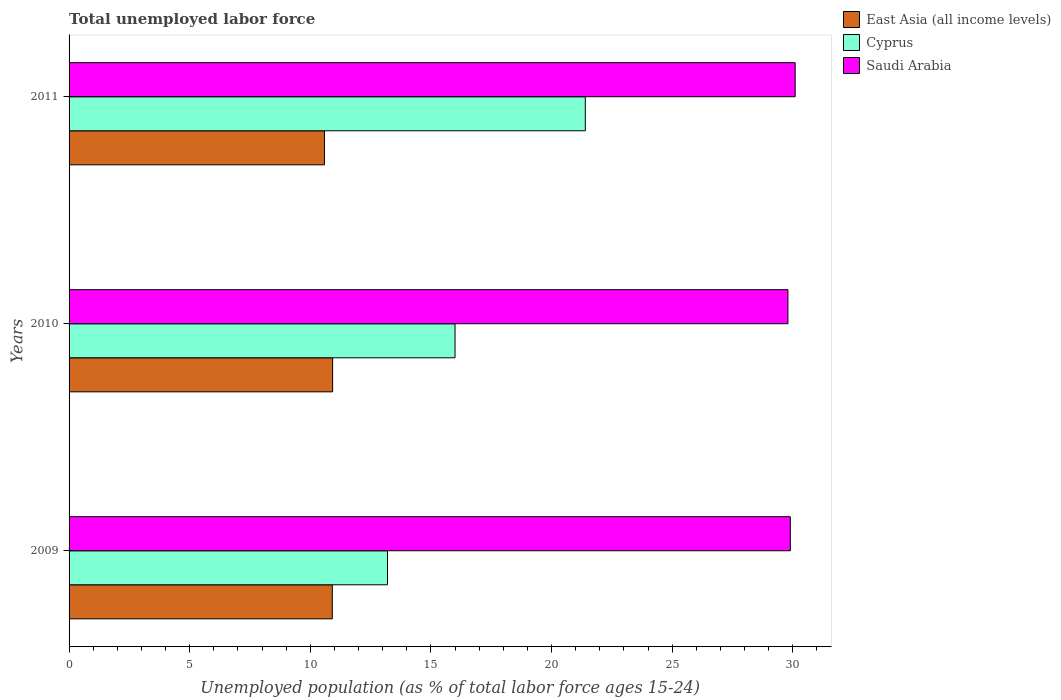How many groups of bars are there?
Your answer should be compact. 3. How many bars are there on the 3rd tick from the top?
Keep it short and to the point. 3. Across all years, what is the maximum percentage of unemployed population in in Saudi Arabia?
Your answer should be compact. 30.1. Across all years, what is the minimum percentage of unemployed population in in East Asia (all income levels)?
Your answer should be very brief. 10.59. In which year was the percentage of unemployed population in in Saudi Arabia maximum?
Your answer should be very brief. 2011. What is the total percentage of unemployed population in in Cyprus in the graph?
Offer a terse response. 50.6. What is the difference between the percentage of unemployed population in in East Asia (all income levels) in 2009 and that in 2011?
Your answer should be very brief. 0.33. What is the difference between the percentage of unemployed population in in East Asia (all income levels) in 2009 and the percentage of unemployed population in in Saudi Arabia in 2011?
Provide a succinct answer. -19.19. What is the average percentage of unemployed population in in Cyprus per year?
Provide a short and direct response. 16.87. In the year 2011, what is the difference between the percentage of unemployed population in in Saudi Arabia and percentage of unemployed population in in Cyprus?
Your response must be concise. 8.7. In how many years, is the percentage of unemployed population in in Cyprus greater than 14 %?
Give a very brief answer. 2. What is the ratio of the percentage of unemployed population in in East Asia (all income levels) in 2010 to that in 2011?
Offer a terse response. 1.03. Is the percentage of unemployed population in in East Asia (all income levels) in 2010 less than that in 2011?
Provide a succinct answer. No. Is the difference between the percentage of unemployed population in in Saudi Arabia in 2009 and 2011 greater than the difference between the percentage of unemployed population in in Cyprus in 2009 and 2011?
Make the answer very short. Yes. What is the difference between the highest and the second highest percentage of unemployed population in in Saudi Arabia?
Offer a terse response. 0.2. What is the difference between the highest and the lowest percentage of unemployed population in in Saudi Arabia?
Your answer should be very brief. 0.3. In how many years, is the percentage of unemployed population in in East Asia (all income levels) greater than the average percentage of unemployed population in in East Asia (all income levels) taken over all years?
Ensure brevity in your answer.  2. Is the sum of the percentage of unemployed population in in East Asia (all income levels) in 2010 and 2011 greater than the maximum percentage of unemployed population in in Saudi Arabia across all years?
Give a very brief answer. No. What does the 2nd bar from the top in 2011 represents?
Keep it short and to the point. Cyprus. What does the 2nd bar from the bottom in 2011 represents?
Make the answer very short. Cyprus. Is it the case that in every year, the sum of the percentage of unemployed population in in Cyprus and percentage of unemployed population in in East Asia (all income levels) is greater than the percentage of unemployed population in in Saudi Arabia?
Make the answer very short. No. Are all the bars in the graph horizontal?
Offer a very short reply. Yes. How many years are there in the graph?
Offer a terse response. 3. What is the difference between two consecutive major ticks on the X-axis?
Ensure brevity in your answer.  5. Are the values on the major ticks of X-axis written in scientific E-notation?
Your answer should be very brief. No. How many legend labels are there?
Ensure brevity in your answer.  3. How are the legend labels stacked?
Provide a short and direct response. Vertical. What is the title of the graph?
Offer a very short reply. Total unemployed labor force. Does "Chad" appear as one of the legend labels in the graph?
Your response must be concise. No. What is the label or title of the X-axis?
Your answer should be compact. Unemployed population (as % of total labor force ages 15-24). What is the label or title of the Y-axis?
Offer a terse response. Years. What is the Unemployed population (as % of total labor force ages 15-24) in East Asia (all income levels) in 2009?
Provide a short and direct response. 10.91. What is the Unemployed population (as % of total labor force ages 15-24) in Cyprus in 2009?
Ensure brevity in your answer.  13.2. What is the Unemployed population (as % of total labor force ages 15-24) of Saudi Arabia in 2009?
Your response must be concise. 29.9. What is the Unemployed population (as % of total labor force ages 15-24) in East Asia (all income levels) in 2010?
Your answer should be compact. 10.93. What is the Unemployed population (as % of total labor force ages 15-24) in Saudi Arabia in 2010?
Your response must be concise. 29.8. What is the Unemployed population (as % of total labor force ages 15-24) in East Asia (all income levels) in 2011?
Offer a very short reply. 10.59. What is the Unemployed population (as % of total labor force ages 15-24) of Cyprus in 2011?
Your answer should be very brief. 21.4. What is the Unemployed population (as % of total labor force ages 15-24) in Saudi Arabia in 2011?
Provide a succinct answer. 30.1. Across all years, what is the maximum Unemployed population (as % of total labor force ages 15-24) of East Asia (all income levels)?
Provide a succinct answer. 10.93. Across all years, what is the maximum Unemployed population (as % of total labor force ages 15-24) in Cyprus?
Keep it short and to the point. 21.4. Across all years, what is the maximum Unemployed population (as % of total labor force ages 15-24) in Saudi Arabia?
Provide a short and direct response. 30.1. Across all years, what is the minimum Unemployed population (as % of total labor force ages 15-24) in East Asia (all income levels)?
Keep it short and to the point. 10.59. Across all years, what is the minimum Unemployed population (as % of total labor force ages 15-24) in Cyprus?
Keep it short and to the point. 13.2. Across all years, what is the minimum Unemployed population (as % of total labor force ages 15-24) of Saudi Arabia?
Keep it short and to the point. 29.8. What is the total Unemployed population (as % of total labor force ages 15-24) of East Asia (all income levels) in the graph?
Provide a succinct answer. 32.42. What is the total Unemployed population (as % of total labor force ages 15-24) in Cyprus in the graph?
Ensure brevity in your answer.  50.6. What is the total Unemployed population (as % of total labor force ages 15-24) in Saudi Arabia in the graph?
Offer a terse response. 89.8. What is the difference between the Unemployed population (as % of total labor force ages 15-24) in East Asia (all income levels) in 2009 and that in 2010?
Your answer should be compact. -0.01. What is the difference between the Unemployed population (as % of total labor force ages 15-24) of Cyprus in 2009 and that in 2010?
Make the answer very short. -2.8. What is the difference between the Unemployed population (as % of total labor force ages 15-24) in East Asia (all income levels) in 2009 and that in 2011?
Your response must be concise. 0.33. What is the difference between the Unemployed population (as % of total labor force ages 15-24) in Saudi Arabia in 2009 and that in 2011?
Give a very brief answer. -0.2. What is the difference between the Unemployed population (as % of total labor force ages 15-24) of East Asia (all income levels) in 2010 and that in 2011?
Your answer should be very brief. 0.34. What is the difference between the Unemployed population (as % of total labor force ages 15-24) of East Asia (all income levels) in 2009 and the Unemployed population (as % of total labor force ages 15-24) of Cyprus in 2010?
Keep it short and to the point. -5.09. What is the difference between the Unemployed population (as % of total labor force ages 15-24) of East Asia (all income levels) in 2009 and the Unemployed population (as % of total labor force ages 15-24) of Saudi Arabia in 2010?
Your answer should be compact. -18.89. What is the difference between the Unemployed population (as % of total labor force ages 15-24) of Cyprus in 2009 and the Unemployed population (as % of total labor force ages 15-24) of Saudi Arabia in 2010?
Your answer should be very brief. -16.6. What is the difference between the Unemployed population (as % of total labor force ages 15-24) in East Asia (all income levels) in 2009 and the Unemployed population (as % of total labor force ages 15-24) in Cyprus in 2011?
Give a very brief answer. -10.49. What is the difference between the Unemployed population (as % of total labor force ages 15-24) in East Asia (all income levels) in 2009 and the Unemployed population (as % of total labor force ages 15-24) in Saudi Arabia in 2011?
Keep it short and to the point. -19.19. What is the difference between the Unemployed population (as % of total labor force ages 15-24) in Cyprus in 2009 and the Unemployed population (as % of total labor force ages 15-24) in Saudi Arabia in 2011?
Make the answer very short. -16.9. What is the difference between the Unemployed population (as % of total labor force ages 15-24) in East Asia (all income levels) in 2010 and the Unemployed population (as % of total labor force ages 15-24) in Cyprus in 2011?
Provide a succinct answer. -10.47. What is the difference between the Unemployed population (as % of total labor force ages 15-24) of East Asia (all income levels) in 2010 and the Unemployed population (as % of total labor force ages 15-24) of Saudi Arabia in 2011?
Your answer should be very brief. -19.17. What is the difference between the Unemployed population (as % of total labor force ages 15-24) in Cyprus in 2010 and the Unemployed population (as % of total labor force ages 15-24) in Saudi Arabia in 2011?
Your answer should be compact. -14.1. What is the average Unemployed population (as % of total labor force ages 15-24) in East Asia (all income levels) per year?
Your response must be concise. 10.81. What is the average Unemployed population (as % of total labor force ages 15-24) of Cyprus per year?
Keep it short and to the point. 16.87. What is the average Unemployed population (as % of total labor force ages 15-24) in Saudi Arabia per year?
Your response must be concise. 29.93. In the year 2009, what is the difference between the Unemployed population (as % of total labor force ages 15-24) of East Asia (all income levels) and Unemployed population (as % of total labor force ages 15-24) of Cyprus?
Give a very brief answer. -2.29. In the year 2009, what is the difference between the Unemployed population (as % of total labor force ages 15-24) in East Asia (all income levels) and Unemployed population (as % of total labor force ages 15-24) in Saudi Arabia?
Ensure brevity in your answer.  -18.99. In the year 2009, what is the difference between the Unemployed population (as % of total labor force ages 15-24) in Cyprus and Unemployed population (as % of total labor force ages 15-24) in Saudi Arabia?
Offer a terse response. -16.7. In the year 2010, what is the difference between the Unemployed population (as % of total labor force ages 15-24) of East Asia (all income levels) and Unemployed population (as % of total labor force ages 15-24) of Cyprus?
Your response must be concise. -5.07. In the year 2010, what is the difference between the Unemployed population (as % of total labor force ages 15-24) of East Asia (all income levels) and Unemployed population (as % of total labor force ages 15-24) of Saudi Arabia?
Provide a succinct answer. -18.87. In the year 2010, what is the difference between the Unemployed population (as % of total labor force ages 15-24) in Cyprus and Unemployed population (as % of total labor force ages 15-24) in Saudi Arabia?
Offer a very short reply. -13.8. In the year 2011, what is the difference between the Unemployed population (as % of total labor force ages 15-24) of East Asia (all income levels) and Unemployed population (as % of total labor force ages 15-24) of Cyprus?
Your answer should be very brief. -10.81. In the year 2011, what is the difference between the Unemployed population (as % of total labor force ages 15-24) of East Asia (all income levels) and Unemployed population (as % of total labor force ages 15-24) of Saudi Arabia?
Offer a very short reply. -19.51. What is the ratio of the Unemployed population (as % of total labor force ages 15-24) of East Asia (all income levels) in 2009 to that in 2010?
Give a very brief answer. 1. What is the ratio of the Unemployed population (as % of total labor force ages 15-24) in Cyprus in 2009 to that in 2010?
Ensure brevity in your answer.  0.82. What is the ratio of the Unemployed population (as % of total labor force ages 15-24) of East Asia (all income levels) in 2009 to that in 2011?
Offer a terse response. 1.03. What is the ratio of the Unemployed population (as % of total labor force ages 15-24) in Cyprus in 2009 to that in 2011?
Offer a terse response. 0.62. What is the ratio of the Unemployed population (as % of total labor force ages 15-24) in Saudi Arabia in 2009 to that in 2011?
Your answer should be very brief. 0.99. What is the ratio of the Unemployed population (as % of total labor force ages 15-24) in East Asia (all income levels) in 2010 to that in 2011?
Make the answer very short. 1.03. What is the ratio of the Unemployed population (as % of total labor force ages 15-24) in Cyprus in 2010 to that in 2011?
Keep it short and to the point. 0.75. What is the ratio of the Unemployed population (as % of total labor force ages 15-24) of Saudi Arabia in 2010 to that in 2011?
Make the answer very short. 0.99. What is the difference between the highest and the second highest Unemployed population (as % of total labor force ages 15-24) in East Asia (all income levels)?
Offer a terse response. 0.01. What is the difference between the highest and the second highest Unemployed population (as % of total labor force ages 15-24) in Cyprus?
Provide a short and direct response. 5.4. What is the difference between the highest and the lowest Unemployed population (as % of total labor force ages 15-24) of East Asia (all income levels)?
Offer a terse response. 0.34. What is the difference between the highest and the lowest Unemployed population (as % of total labor force ages 15-24) of Cyprus?
Give a very brief answer. 8.2. 